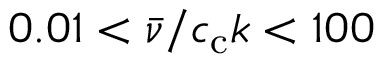<formula> <loc_0><loc_0><loc_500><loc_500>0 . 0 1 < \bar { \nu } / c _ { c } k < 1 0 0</formula> 